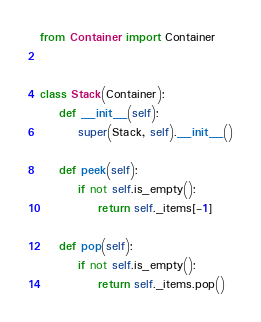<code> <loc_0><loc_0><loc_500><loc_500><_Python_>from Container import Container


class Stack(Container):
    def __init__(self):
        super(Stack, self).__init__()

    def peek(self):
        if not self.is_empty():
            return self._items[-1]

    def pop(self):
        if not self.is_empty():
            return self._items.pop()
</code> 